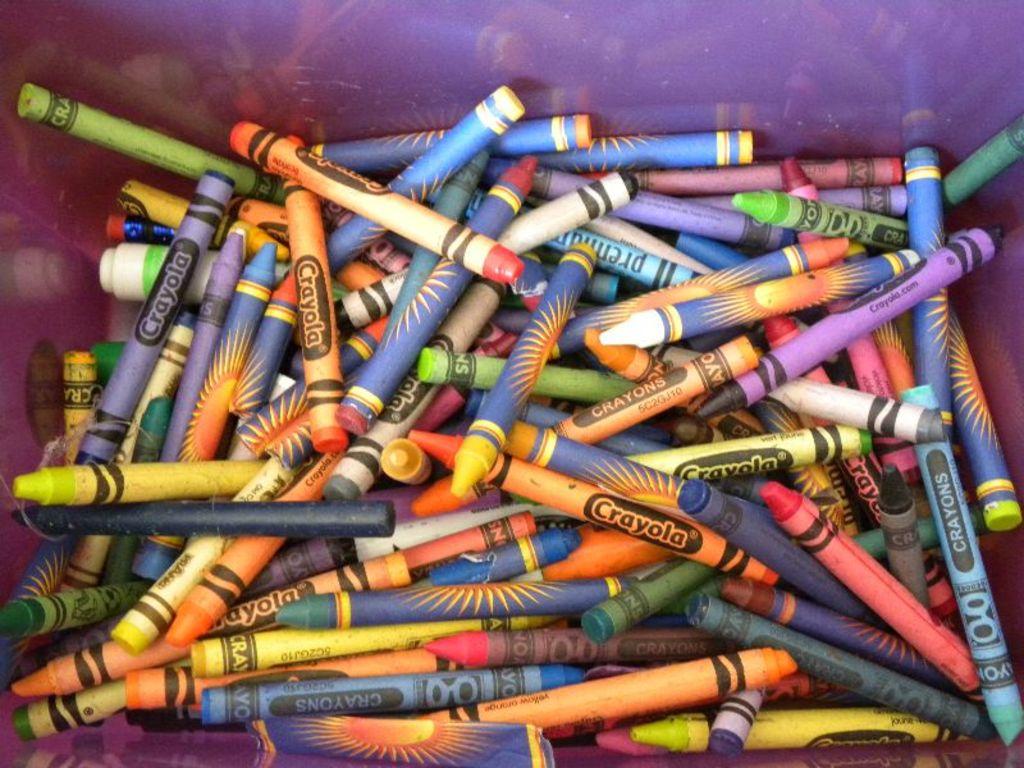What color is cited on the crayon at the bottom middle of the picture?
Provide a short and direct response. Unanswerable. What brand are these crayons?
Your answer should be very brief. Crayola. 